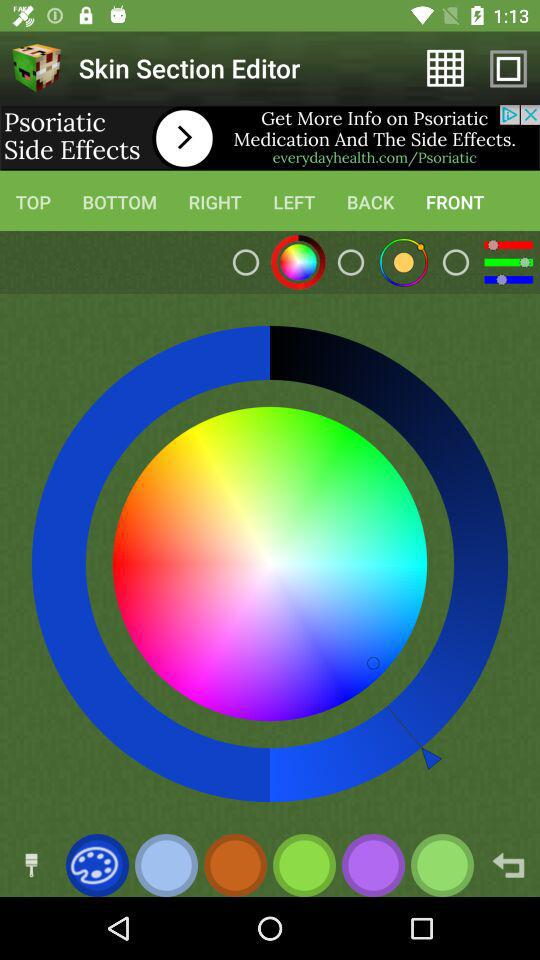What is the app name? The app name is "Skin Section Editor". 